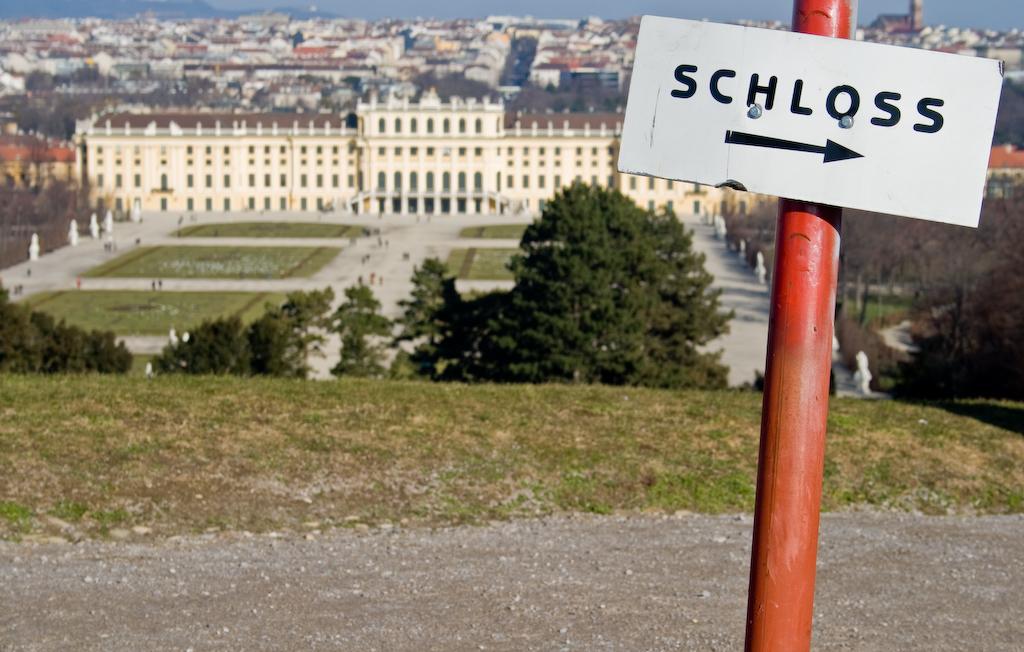What is on the sign?
Offer a very short reply. Schloss. 